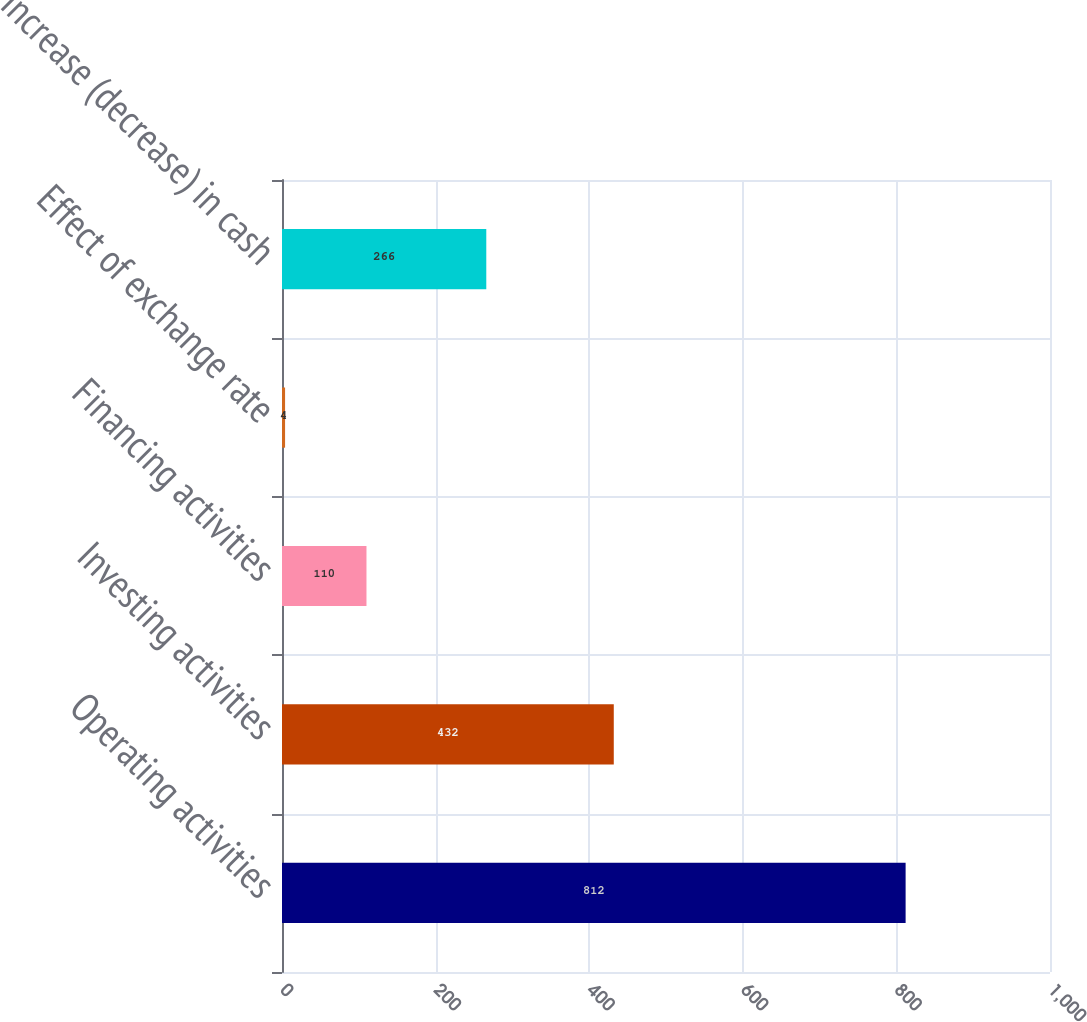Convert chart. <chart><loc_0><loc_0><loc_500><loc_500><bar_chart><fcel>Operating activities<fcel>Investing activities<fcel>Financing activities<fcel>Effect of exchange rate<fcel>Increase (decrease) in cash<nl><fcel>812<fcel>432<fcel>110<fcel>4<fcel>266<nl></chart> 